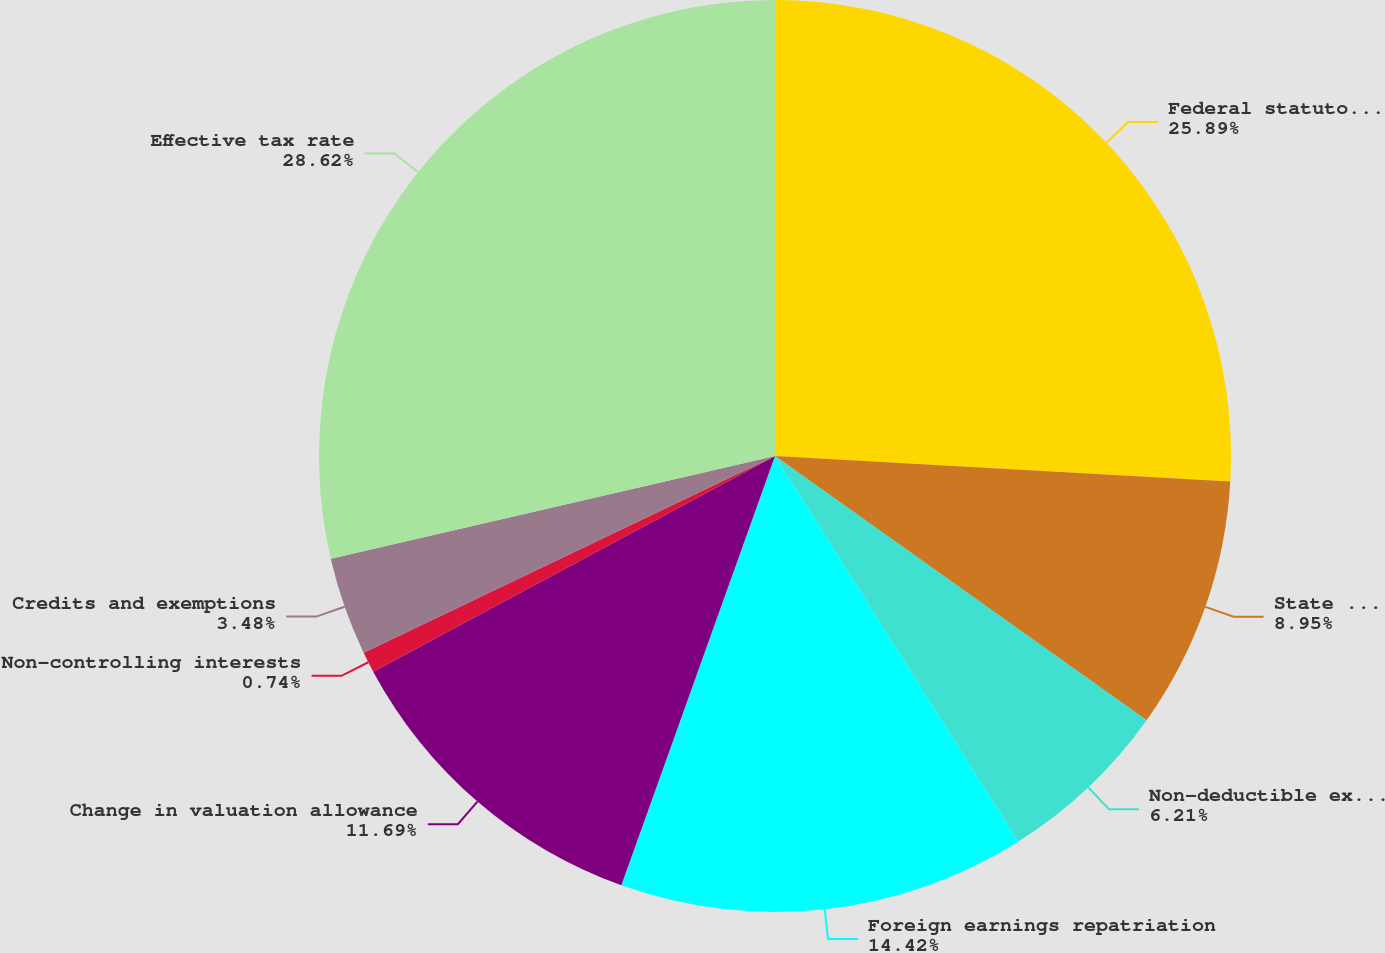Convert chart to OTSL. <chart><loc_0><loc_0><loc_500><loc_500><pie_chart><fcel>Federal statutory tax rate<fcel>State taxes net of federal<fcel>Non-deductible expenses<fcel>Foreign earnings repatriation<fcel>Change in valuation allowance<fcel>Non-controlling interests<fcel>Credits and exemptions<fcel>Effective tax rate<nl><fcel>25.89%<fcel>8.95%<fcel>6.21%<fcel>14.42%<fcel>11.69%<fcel>0.74%<fcel>3.48%<fcel>28.62%<nl></chart> 